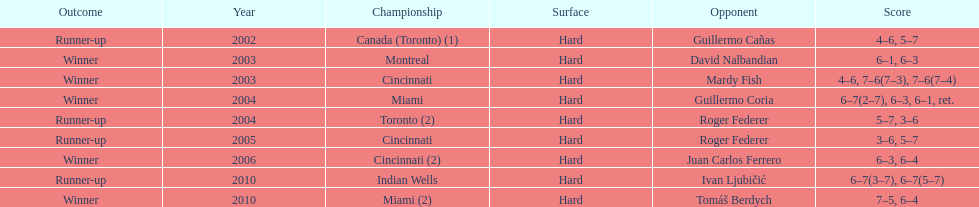How many wins does he have in total? 5. 